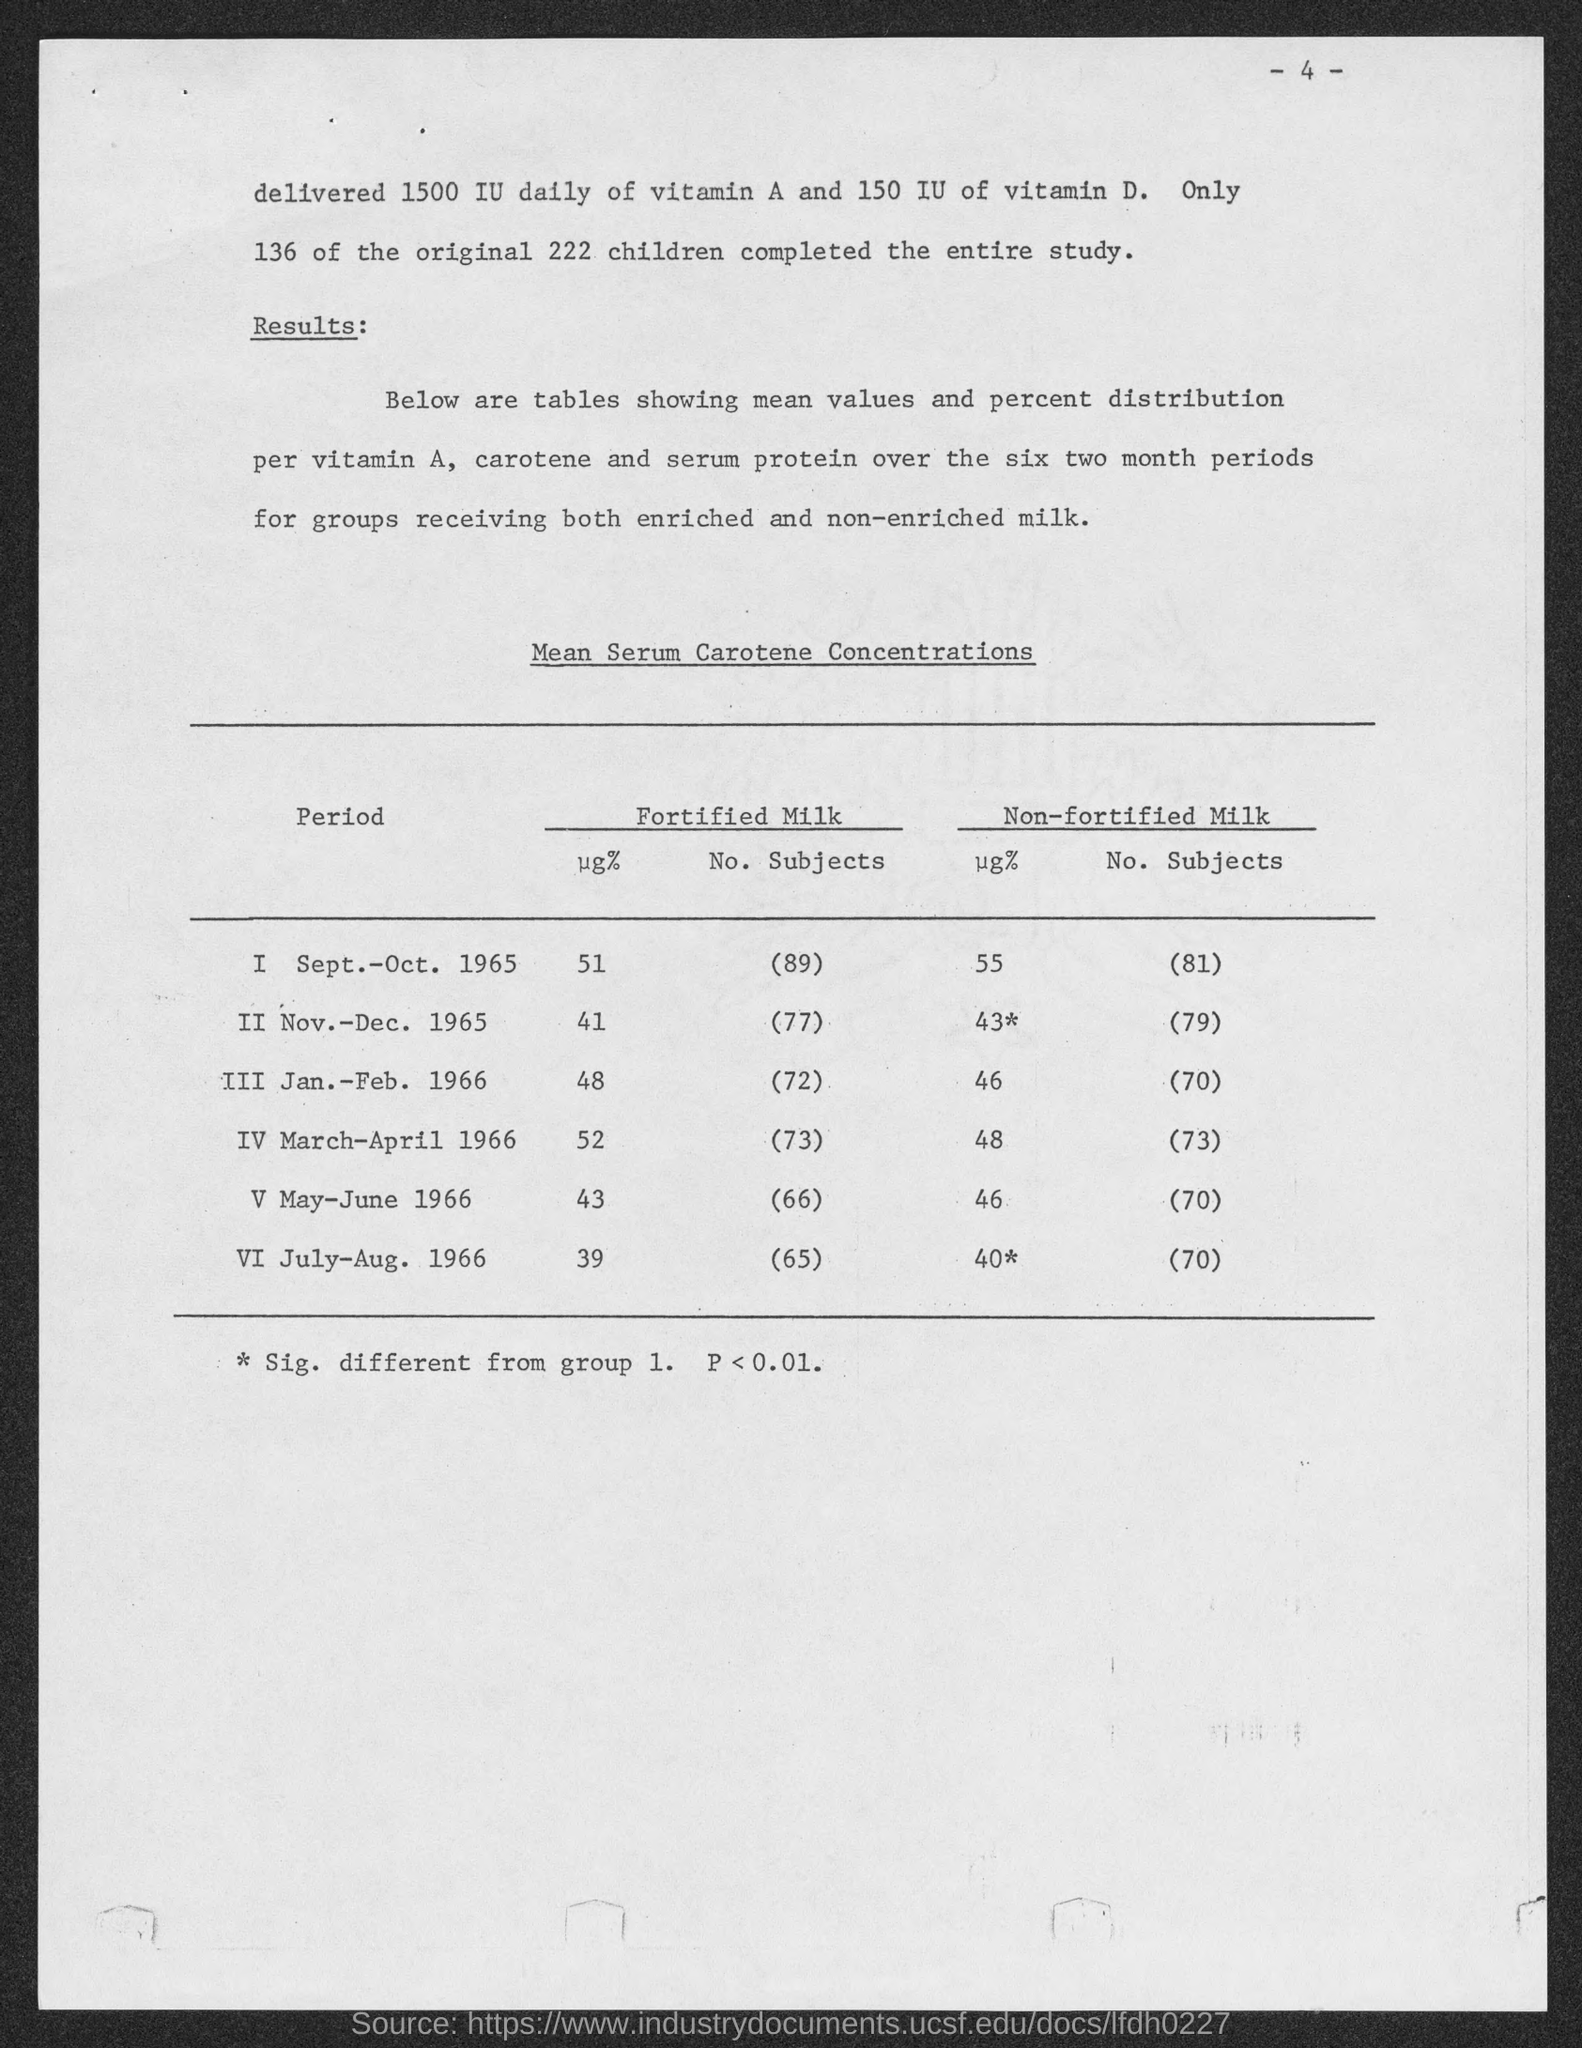How many children completed the entire study?
Provide a succinct answer. 136. What were the total number of children?
Ensure brevity in your answer.  222. What is the No. Subjects who had Fortified Milk during the period of Sept.-Oct. 1965?
Your answer should be compact. 89. What is the No. Subjects who had Non-Fortified Milk during the period of Sept.-Oct. 1965?
Provide a succinct answer. 81. 